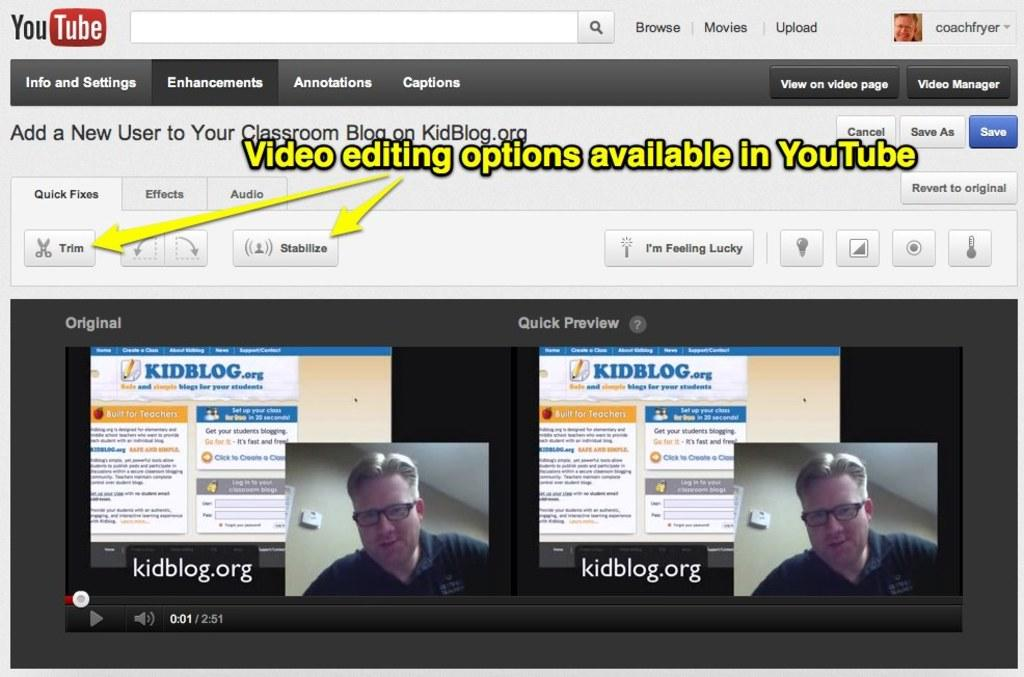What is the main subject of the image? The main subject of the image is a website. Is there anyone present in the image? Yes, there is a person in the image. What else can be seen in the image besides the website and person? There is text in the image. What type of wood can be seen in the image? There is no wood present in the image; it features a website and a person. How many beds are visible in the image? There are no beds present in the image. 